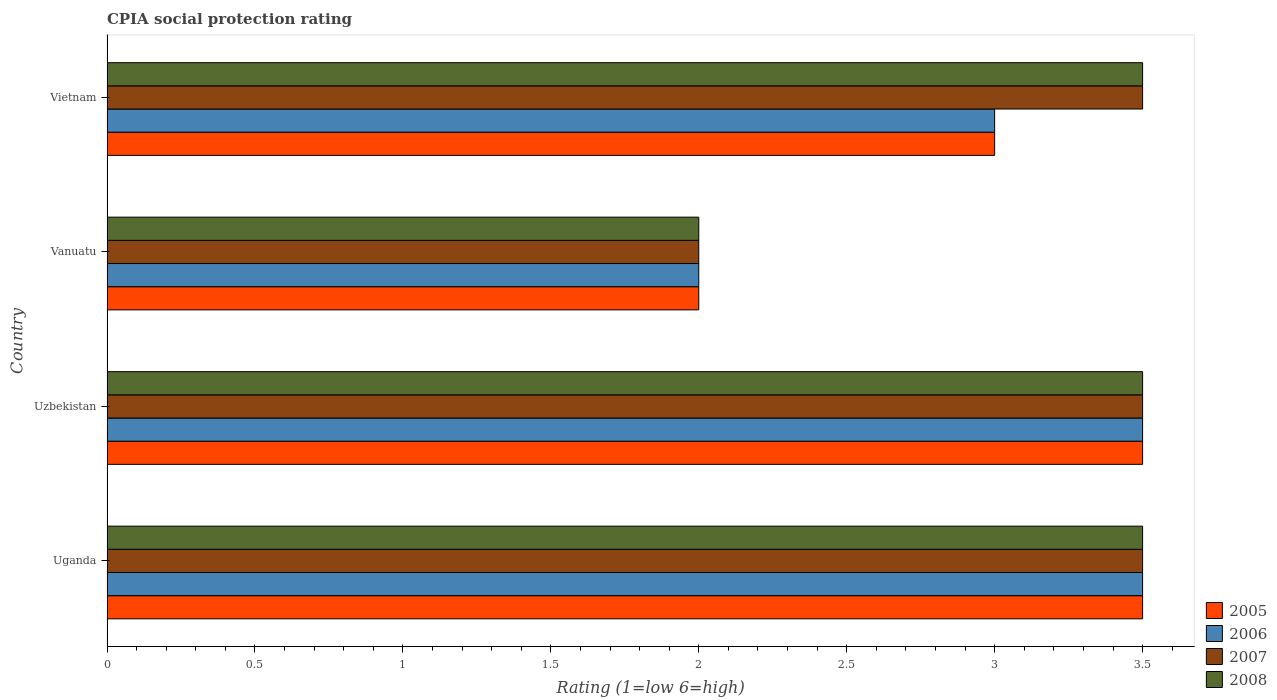How many groups of bars are there?
Offer a terse response. 4. Are the number of bars per tick equal to the number of legend labels?
Offer a very short reply. Yes. What is the label of the 4th group of bars from the top?
Provide a short and direct response. Uganda. What is the CPIA rating in 2005 in Vietnam?
Keep it short and to the point. 3. Across all countries, what is the maximum CPIA rating in 2005?
Offer a terse response. 3.5. Across all countries, what is the minimum CPIA rating in 2007?
Ensure brevity in your answer.  2. In which country was the CPIA rating in 2005 maximum?
Offer a terse response. Uganda. In which country was the CPIA rating in 2008 minimum?
Offer a terse response. Vanuatu. What is the total CPIA rating in 2005 in the graph?
Provide a succinct answer. 12. What is the difference between the CPIA rating in 2005 in Vanuatu and that in Vietnam?
Provide a succinct answer. -1. What is the average CPIA rating in 2008 per country?
Give a very brief answer. 3.12. What is the difference between the CPIA rating in 2006 and CPIA rating in 2005 in Vietnam?
Ensure brevity in your answer.  0. What is the ratio of the CPIA rating in 2005 in Uzbekistan to that in Vanuatu?
Provide a short and direct response. 1.75. Is the difference between the CPIA rating in 2006 in Uzbekistan and Vanuatu greater than the difference between the CPIA rating in 2005 in Uzbekistan and Vanuatu?
Offer a terse response. No. What is the difference between the highest and the second highest CPIA rating in 2005?
Ensure brevity in your answer.  0. What is the difference between the highest and the lowest CPIA rating in 2006?
Your answer should be very brief. 1.5. Is the sum of the CPIA rating in 2008 in Uzbekistan and Vietnam greater than the maximum CPIA rating in 2007 across all countries?
Keep it short and to the point. Yes. Is it the case that in every country, the sum of the CPIA rating in 2006 and CPIA rating in 2008 is greater than the sum of CPIA rating in 2005 and CPIA rating in 2007?
Your answer should be compact. No. What does the 2nd bar from the bottom in Uganda represents?
Make the answer very short. 2006. Are all the bars in the graph horizontal?
Your response must be concise. Yes. Are the values on the major ticks of X-axis written in scientific E-notation?
Give a very brief answer. No. What is the title of the graph?
Provide a short and direct response. CPIA social protection rating. What is the label or title of the Y-axis?
Offer a very short reply. Country. What is the Rating (1=low 6=high) of 2007 in Uganda?
Offer a terse response. 3.5. What is the Rating (1=low 6=high) of 2008 in Uganda?
Keep it short and to the point. 3.5. What is the Rating (1=low 6=high) of 2007 in Uzbekistan?
Your answer should be very brief. 3.5. What is the Rating (1=low 6=high) in 2007 in Vanuatu?
Provide a succinct answer. 2. What is the Rating (1=low 6=high) in 2005 in Vietnam?
Offer a terse response. 3. What is the Rating (1=low 6=high) in 2006 in Vietnam?
Make the answer very short. 3. What is the Rating (1=low 6=high) of 2007 in Vietnam?
Your answer should be compact. 3.5. What is the Rating (1=low 6=high) of 2008 in Vietnam?
Your answer should be compact. 3.5. Across all countries, what is the maximum Rating (1=low 6=high) of 2005?
Give a very brief answer. 3.5. Across all countries, what is the maximum Rating (1=low 6=high) of 2007?
Offer a terse response. 3.5. Across all countries, what is the minimum Rating (1=low 6=high) in 2005?
Your answer should be very brief. 2. Across all countries, what is the minimum Rating (1=low 6=high) of 2006?
Provide a succinct answer. 2. Across all countries, what is the minimum Rating (1=low 6=high) in 2007?
Your answer should be compact. 2. Across all countries, what is the minimum Rating (1=low 6=high) in 2008?
Provide a short and direct response. 2. What is the total Rating (1=low 6=high) of 2007 in the graph?
Offer a very short reply. 12.5. What is the difference between the Rating (1=low 6=high) of 2007 in Uganda and that in Uzbekistan?
Offer a very short reply. 0. What is the difference between the Rating (1=low 6=high) in 2005 in Uganda and that in Vietnam?
Ensure brevity in your answer.  0.5. What is the difference between the Rating (1=low 6=high) of 2008 in Uganda and that in Vietnam?
Offer a terse response. 0. What is the difference between the Rating (1=low 6=high) of 2005 in Uzbekistan and that in Vanuatu?
Offer a terse response. 1.5. What is the difference between the Rating (1=low 6=high) of 2005 in Uzbekistan and that in Vietnam?
Provide a succinct answer. 0.5. What is the difference between the Rating (1=low 6=high) in 2006 in Uzbekistan and that in Vietnam?
Ensure brevity in your answer.  0.5. What is the difference between the Rating (1=low 6=high) in 2005 in Vanuatu and that in Vietnam?
Make the answer very short. -1. What is the difference between the Rating (1=low 6=high) in 2005 in Uganda and the Rating (1=low 6=high) in 2006 in Uzbekistan?
Offer a very short reply. 0. What is the difference between the Rating (1=low 6=high) in 2005 in Uganda and the Rating (1=low 6=high) in 2007 in Uzbekistan?
Provide a short and direct response. 0. What is the difference between the Rating (1=low 6=high) of 2005 in Uganda and the Rating (1=low 6=high) of 2008 in Uzbekistan?
Your answer should be very brief. 0. What is the difference between the Rating (1=low 6=high) in 2006 in Uganda and the Rating (1=low 6=high) in 2007 in Uzbekistan?
Give a very brief answer. 0. What is the difference between the Rating (1=low 6=high) of 2006 in Uganda and the Rating (1=low 6=high) of 2008 in Uzbekistan?
Keep it short and to the point. 0. What is the difference between the Rating (1=low 6=high) of 2005 in Uganda and the Rating (1=low 6=high) of 2007 in Vanuatu?
Your response must be concise. 1.5. What is the difference between the Rating (1=low 6=high) of 2005 in Uganda and the Rating (1=low 6=high) of 2008 in Vanuatu?
Give a very brief answer. 1.5. What is the difference between the Rating (1=low 6=high) of 2005 in Uganda and the Rating (1=low 6=high) of 2007 in Vietnam?
Your answer should be compact. 0. What is the difference between the Rating (1=low 6=high) in 2006 in Uganda and the Rating (1=low 6=high) in 2007 in Vietnam?
Provide a succinct answer. 0. What is the difference between the Rating (1=low 6=high) of 2006 in Uganda and the Rating (1=low 6=high) of 2008 in Vietnam?
Provide a succinct answer. 0. What is the difference between the Rating (1=low 6=high) of 2005 in Uzbekistan and the Rating (1=low 6=high) of 2006 in Vanuatu?
Make the answer very short. 1.5. What is the difference between the Rating (1=low 6=high) of 2005 in Uzbekistan and the Rating (1=low 6=high) of 2007 in Vanuatu?
Keep it short and to the point. 1.5. What is the difference between the Rating (1=low 6=high) in 2005 in Uzbekistan and the Rating (1=low 6=high) in 2008 in Vanuatu?
Provide a succinct answer. 1.5. What is the difference between the Rating (1=low 6=high) of 2006 in Uzbekistan and the Rating (1=low 6=high) of 2008 in Vanuatu?
Offer a very short reply. 1.5. What is the difference between the Rating (1=low 6=high) in 2007 in Uzbekistan and the Rating (1=low 6=high) in 2008 in Vanuatu?
Ensure brevity in your answer.  1.5. What is the difference between the Rating (1=low 6=high) in 2005 in Uzbekistan and the Rating (1=low 6=high) in 2007 in Vietnam?
Ensure brevity in your answer.  0. What is the difference between the Rating (1=low 6=high) in 2005 in Uzbekistan and the Rating (1=low 6=high) in 2008 in Vietnam?
Make the answer very short. 0. What is the difference between the Rating (1=low 6=high) of 2006 in Uzbekistan and the Rating (1=low 6=high) of 2007 in Vietnam?
Ensure brevity in your answer.  0. What is the difference between the Rating (1=low 6=high) of 2006 in Uzbekistan and the Rating (1=low 6=high) of 2008 in Vietnam?
Offer a terse response. 0. What is the difference between the Rating (1=low 6=high) of 2005 in Vanuatu and the Rating (1=low 6=high) of 2006 in Vietnam?
Keep it short and to the point. -1. What is the difference between the Rating (1=low 6=high) in 2005 in Vanuatu and the Rating (1=low 6=high) in 2007 in Vietnam?
Offer a terse response. -1.5. What is the difference between the Rating (1=low 6=high) in 2006 in Vanuatu and the Rating (1=low 6=high) in 2007 in Vietnam?
Provide a succinct answer. -1.5. What is the difference between the Rating (1=low 6=high) in 2006 in Vanuatu and the Rating (1=low 6=high) in 2008 in Vietnam?
Your answer should be compact. -1.5. What is the average Rating (1=low 6=high) in 2005 per country?
Provide a short and direct response. 3. What is the average Rating (1=low 6=high) of 2006 per country?
Ensure brevity in your answer.  3. What is the average Rating (1=low 6=high) of 2007 per country?
Make the answer very short. 3.12. What is the average Rating (1=low 6=high) of 2008 per country?
Make the answer very short. 3.12. What is the difference between the Rating (1=low 6=high) of 2005 and Rating (1=low 6=high) of 2006 in Uganda?
Ensure brevity in your answer.  0. What is the difference between the Rating (1=low 6=high) in 2005 and Rating (1=low 6=high) in 2007 in Uganda?
Your response must be concise. 0. What is the difference between the Rating (1=low 6=high) of 2005 and Rating (1=low 6=high) of 2008 in Uganda?
Make the answer very short. 0. What is the difference between the Rating (1=low 6=high) in 2005 and Rating (1=low 6=high) in 2006 in Vanuatu?
Offer a terse response. 0. What is the difference between the Rating (1=low 6=high) in 2005 and Rating (1=low 6=high) in 2007 in Vanuatu?
Provide a short and direct response. 0. What is the difference between the Rating (1=low 6=high) of 2005 and Rating (1=low 6=high) of 2008 in Vanuatu?
Offer a very short reply. 0. What is the difference between the Rating (1=low 6=high) in 2005 and Rating (1=low 6=high) in 2007 in Vietnam?
Your response must be concise. -0.5. What is the difference between the Rating (1=low 6=high) of 2005 and Rating (1=low 6=high) of 2008 in Vietnam?
Offer a terse response. -0.5. What is the difference between the Rating (1=low 6=high) of 2006 and Rating (1=low 6=high) of 2007 in Vietnam?
Ensure brevity in your answer.  -0.5. What is the ratio of the Rating (1=low 6=high) of 2005 in Uganda to that in Uzbekistan?
Offer a terse response. 1. What is the ratio of the Rating (1=low 6=high) in 2006 in Uganda to that in Uzbekistan?
Your response must be concise. 1. What is the ratio of the Rating (1=low 6=high) in 2007 in Uganda to that in Uzbekistan?
Provide a succinct answer. 1. What is the ratio of the Rating (1=low 6=high) of 2005 in Uganda to that in Vietnam?
Ensure brevity in your answer.  1.17. What is the ratio of the Rating (1=low 6=high) in 2006 in Uganda to that in Vietnam?
Your response must be concise. 1.17. What is the ratio of the Rating (1=low 6=high) in 2008 in Uganda to that in Vietnam?
Make the answer very short. 1. What is the ratio of the Rating (1=low 6=high) of 2005 in Uzbekistan to that in Vanuatu?
Ensure brevity in your answer.  1.75. What is the ratio of the Rating (1=low 6=high) of 2006 in Uzbekistan to that in Vanuatu?
Offer a terse response. 1.75. What is the ratio of the Rating (1=low 6=high) in 2005 in Uzbekistan to that in Vietnam?
Make the answer very short. 1.17. What is the ratio of the Rating (1=low 6=high) of 2006 in Uzbekistan to that in Vietnam?
Offer a terse response. 1.17. What is the ratio of the Rating (1=low 6=high) in 2007 in Uzbekistan to that in Vietnam?
Ensure brevity in your answer.  1. What is the ratio of the Rating (1=low 6=high) in 2005 in Vanuatu to that in Vietnam?
Provide a short and direct response. 0.67. What is the difference between the highest and the second highest Rating (1=low 6=high) in 2005?
Offer a very short reply. 0. What is the difference between the highest and the second highest Rating (1=low 6=high) of 2006?
Your response must be concise. 0. What is the difference between the highest and the second highest Rating (1=low 6=high) in 2007?
Your answer should be very brief. 0. What is the difference between the highest and the lowest Rating (1=low 6=high) of 2005?
Your response must be concise. 1.5. 